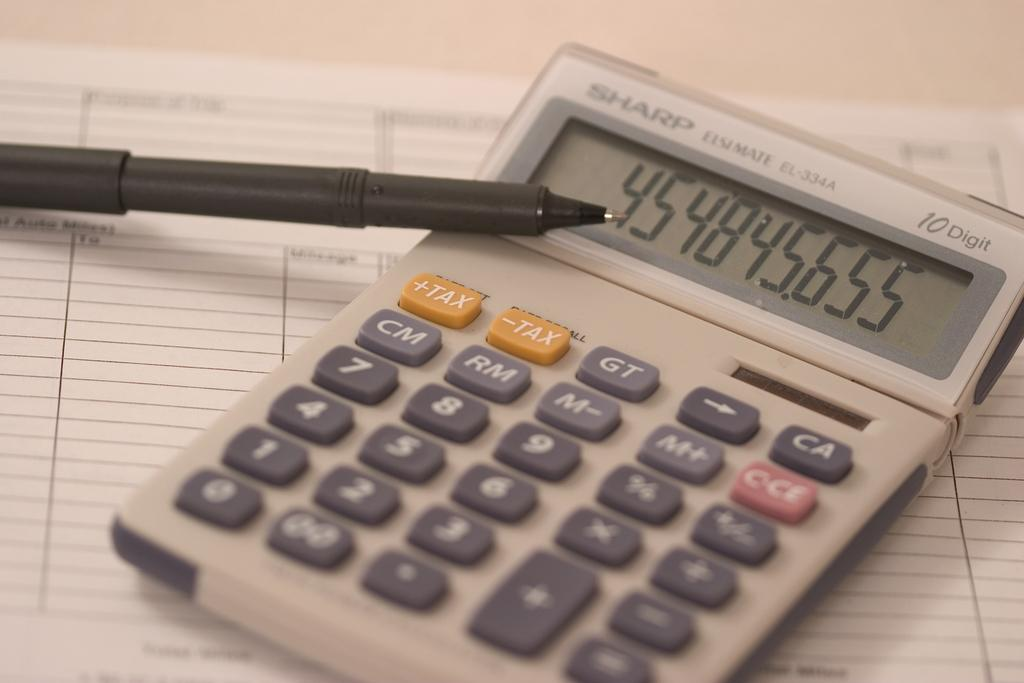<image>
Summarize the visual content of the image. A calculator resting on a piece of paper with a pen leaning against it shows that the last number calculated was 454845.655 